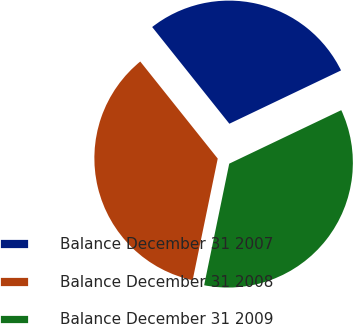<chart> <loc_0><loc_0><loc_500><loc_500><pie_chart><fcel>Balance December 31 2007<fcel>Balance December 31 2008<fcel>Balance December 31 2009<nl><fcel>28.63%<fcel>36.04%<fcel>35.33%<nl></chart> 